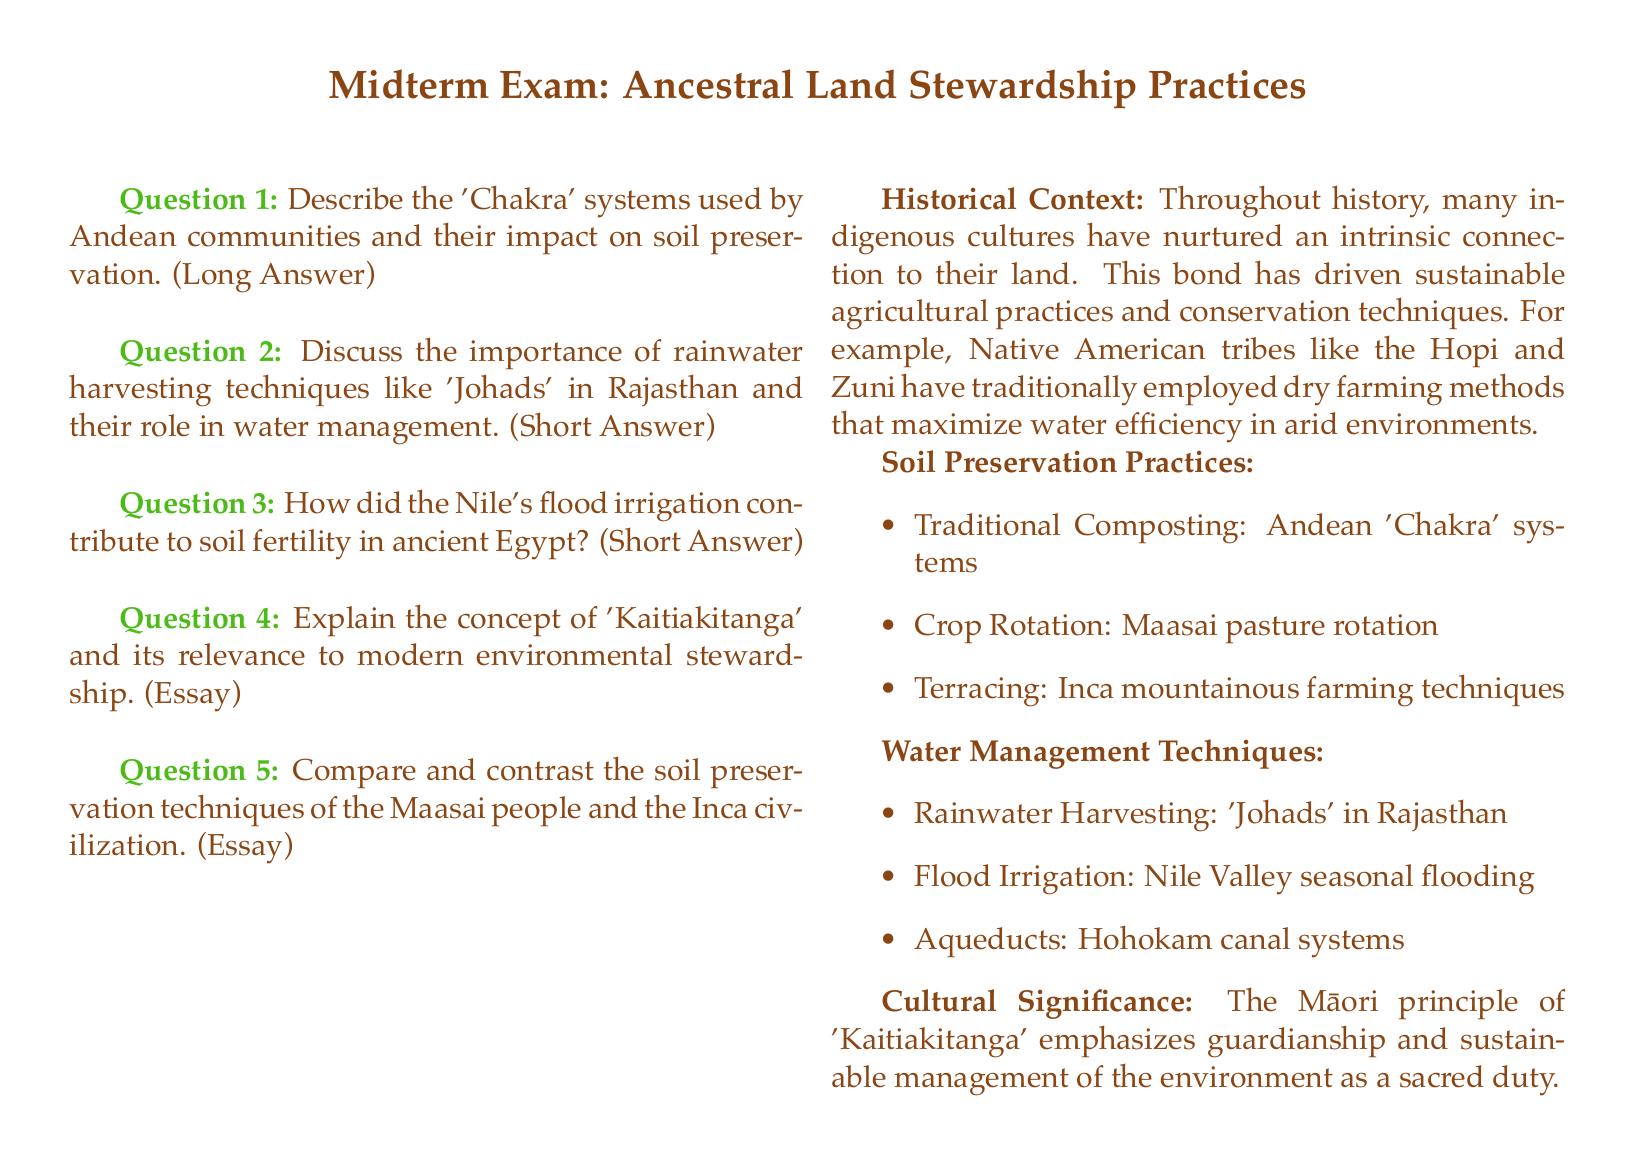What is the first question in the midterm exam? The first question in the midterm exam asks about the 'Chakra' systems used by Andean communities and their impact on soil preservation.
Answer: Describe the 'Chakra' systems What is the cultural principle emphasized by Māori regarding environmental management? The document mentions the Māori principle related to guardianship and sustainable management of the environment.
Answer: Kaitiakitanga What water management technique is associated with the Hohokam civilization? The document lists the Hohokam civilization's water management technique concerning their canal systems.
Answer: Aqueducts What traditional farming method do the Hopi and Zuni Native American tribes employ? The document discusses the dry farming methods used by Hopi and Zuni tribes to maximize water efficiency in arid environments.
Answer: Dry farming Which ancient civilization utilized flood irrigation to enhance soil fertility? The document describes ancient Egypt's method of using Nile floods for irrigation.
Answer: Ancient Egypt What is one of the soil preservation practices listed in the document? The document provides several soil preservation practices, including traditional composting methods.
Answer: Traditional Composting How do the Maasai people approach soil preservation? The document highlights a specific technique that the Maasai use related to their traditional practices for preserving soil.
Answer: Pasture rotation What is the purpose of rainwater harvesting techniques like 'Johads'? The document specifies the role of 'Johads' in managing water resources in a particular region.
Answer: Water management What is the second question in the midterm exam focusing on? The second question concerns the significance of a specific rainwater harvesting technique in Rajasthan.
Answer: Importance of rainwater harvesting techniques 